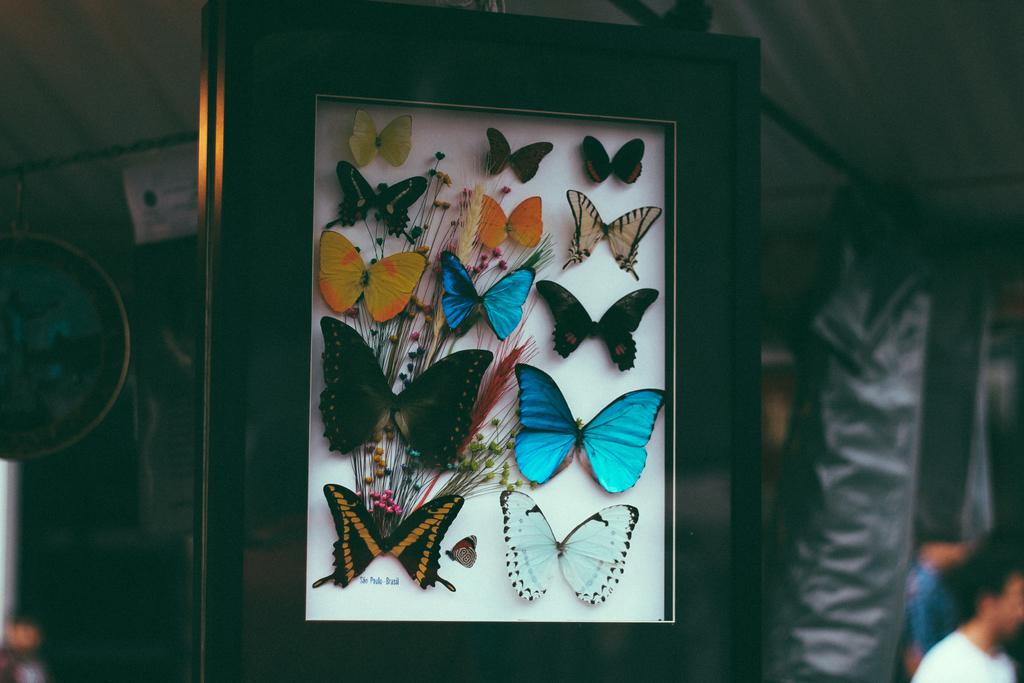What type of animals can be seen in the image? There are butterflies in the image. Where are the butterflies located in the image? The butterflies are in the front of the image. What can be seen in the background of the image? There are black objects in the background of the image. Is there any human presence in the image? Yes, there is a person visible in the image. What type of cherries can be seen growing in the image? There are no cherries present in the image, and no growth or plant life is mentioned in the facts provided. 